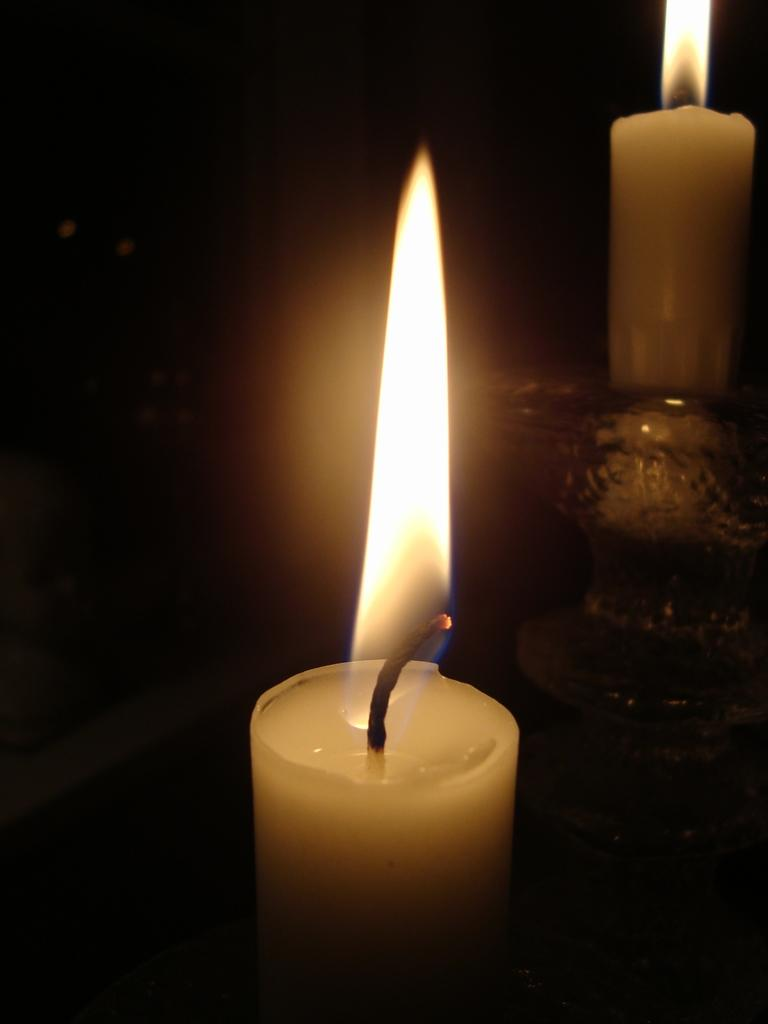How many candles are visible in the image? There are two candles in the image. Where is one of the candles placed? One candle is placed in a bowl. What color is the background of the image? The background of the image is black. What type of flowers can be seen growing in the image? There are no flowers present in the image. Can you describe the argument taking place between the candles in the image? There is no argument taking place between the candles in the image, as candles do not engage in arguments. 